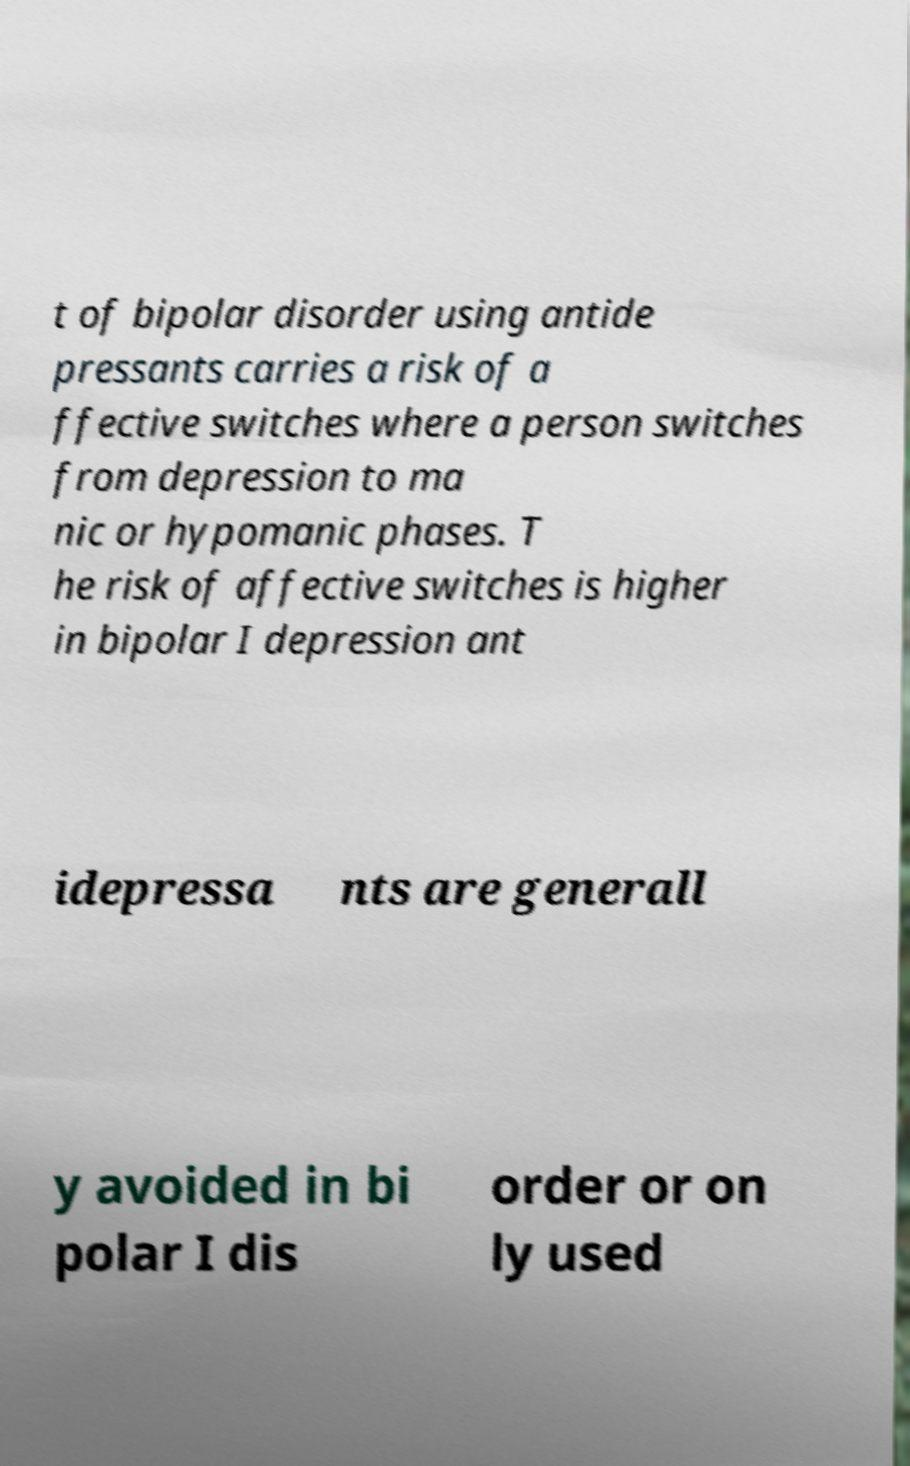What messages or text are displayed in this image? I need them in a readable, typed format. t of bipolar disorder using antide pressants carries a risk of a ffective switches where a person switches from depression to ma nic or hypomanic phases. T he risk of affective switches is higher in bipolar I depression ant idepressa nts are generall y avoided in bi polar I dis order or on ly used 